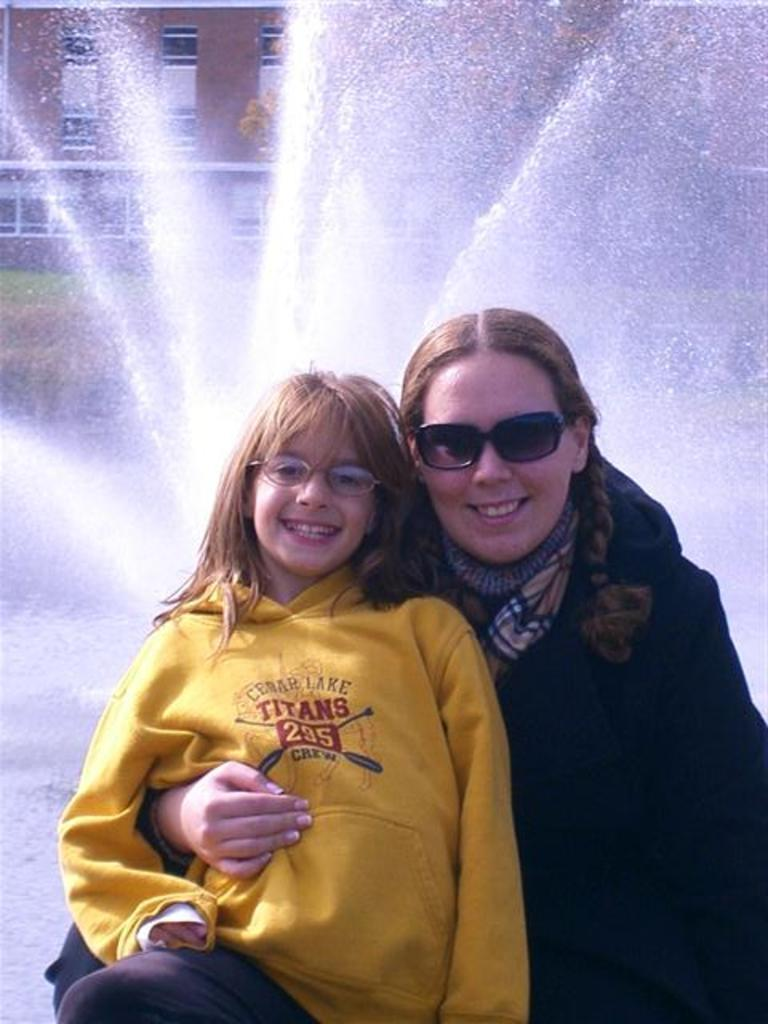Who is present in the image? There is a girl and a woman in the image. What are the expressions of the girl and the woman? The girl and the woman are both smiling. What can be seen in the background of the image? There is a building in the background of the image. What is the main feature in the foreground of the image? There is a water fountain in the image. What type of quartz can be seen in the image? There is no quartz present in the image. How many geese are visible in the image? There are no geese present in the image. 